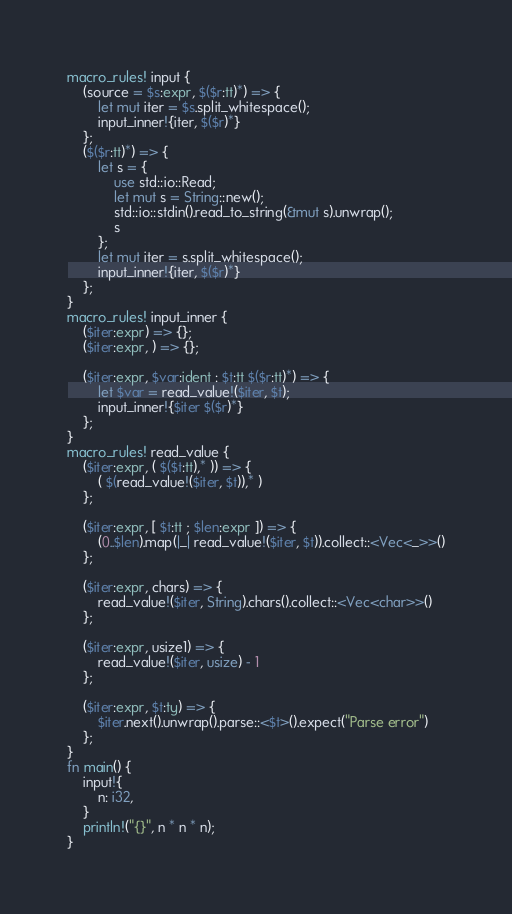<code> <loc_0><loc_0><loc_500><loc_500><_Rust_>macro_rules! input {
    (source = $s:expr, $($r:tt)*) => {
        let mut iter = $s.split_whitespace();
        input_inner!{iter, $($r)*}
    };
    ($($r:tt)*) => {
        let s = {
            use std::io::Read;
            let mut s = String::new();
            std::io::stdin().read_to_string(&mut s).unwrap();
            s
        };
        let mut iter = s.split_whitespace();
        input_inner!{iter, $($r)*}
    };
}
macro_rules! input_inner {
    ($iter:expr) => {};
    ($iter:expr, ) => {};

    ($iter:expr, $var:ident : $t:tt $($r:tt)*) => {
        let $var = read_value!($iter, $t);
        input_inner!{$iter $($r)*}
    };
}
macro_rules! read_value {
    ($iter:expr, ( $($t:tt),* )) => {
        ( $(read_value!($iter, $t)),* )
    };

    ($iter:expr, [ $t:tt ; $len:expr ]) => {
        (0..$len).map(|_| read_value!($iter, $t)).collect::<Vec<_>>()
    };

    ($iter:expr, chars) => {
        read_value!($iter, String).chars().collect::<Vec<char>>()
    };

    ($iter:expr, usize1) => {
        read_value!($iter, usize) - 1
    };

    ($iter:expr, $t:ty) => {
        $iter.next().unwrap().parse::<$t>().expect("Parse error")
    };
}
fn main() {
    input!{
        n: i32,
    }
    println!("{}", n * n * n);
}
</code> 